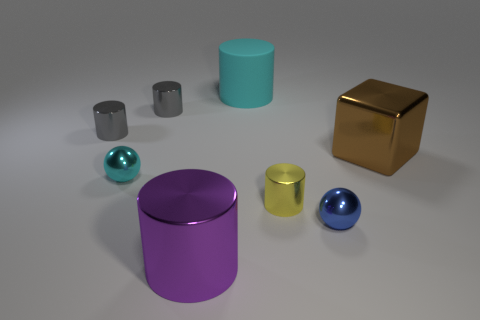Does the cyan metallic thing have the same shape as the large cyan matte thing?
Ensure brevity in your answer.  No. Are there an equal number of big purple shiny things on the left side of the tiny cyan object and big purple cylinders to the right of the blue ball?
Provide a succinct answer. Yes. What is the color of the big cylinder that is made of the same material as the big cube?
Your answer should be compact. Purple. What number of tiny gray cylinders have the same material as the cyan sphere?
Your answer should be very brief. 2. There is a shiny ball in front of the tiny cyan object; is it the same color as the matte cylinder?
Your response must be concise. No. What number of blue metallic things are the same shape as the tiny cyan thing?
Offer a very short reply. 1. Are there an equal number of metal things on the right side of the brown shiny cube and blue shiny things?
Provide a short and direct response. No. What color is the shiny object that is the same size as the purple metallic cylinder?
Keep it short and to the point. Brown. Is there a big purple object that has the same shape as the yellow thing?
Make the answer very short. Yes. There is a large thing that is right of the cyan matte cylinder that is behind the cylinder to the right of the matte cylinder; what is it made of?
Make the answer very short. Metal. 